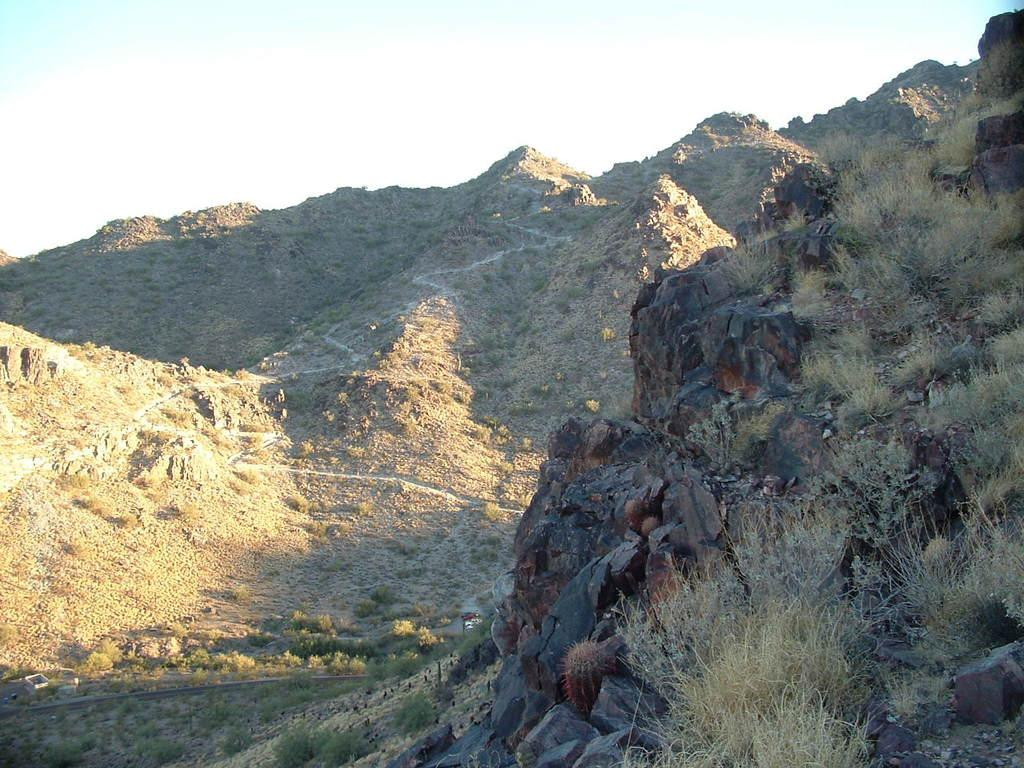What type of natural formation can be seen in the image? There are mountains in the image. What type of vegetation is on the right side of the image? There is grass on the right side of the image. What type of small objects are visible at the top of the image? Small stones are visible at the top of the image. What is visible at the top of the image? The sky is visible at the top of the image. How many clocks are hanging from the mountains in the image? There are no clocks visible in the image; it features mountains, grass, small stones, and the sky. Can you see a ring on the grass in the image? There is no ring present on the grass in the image. 